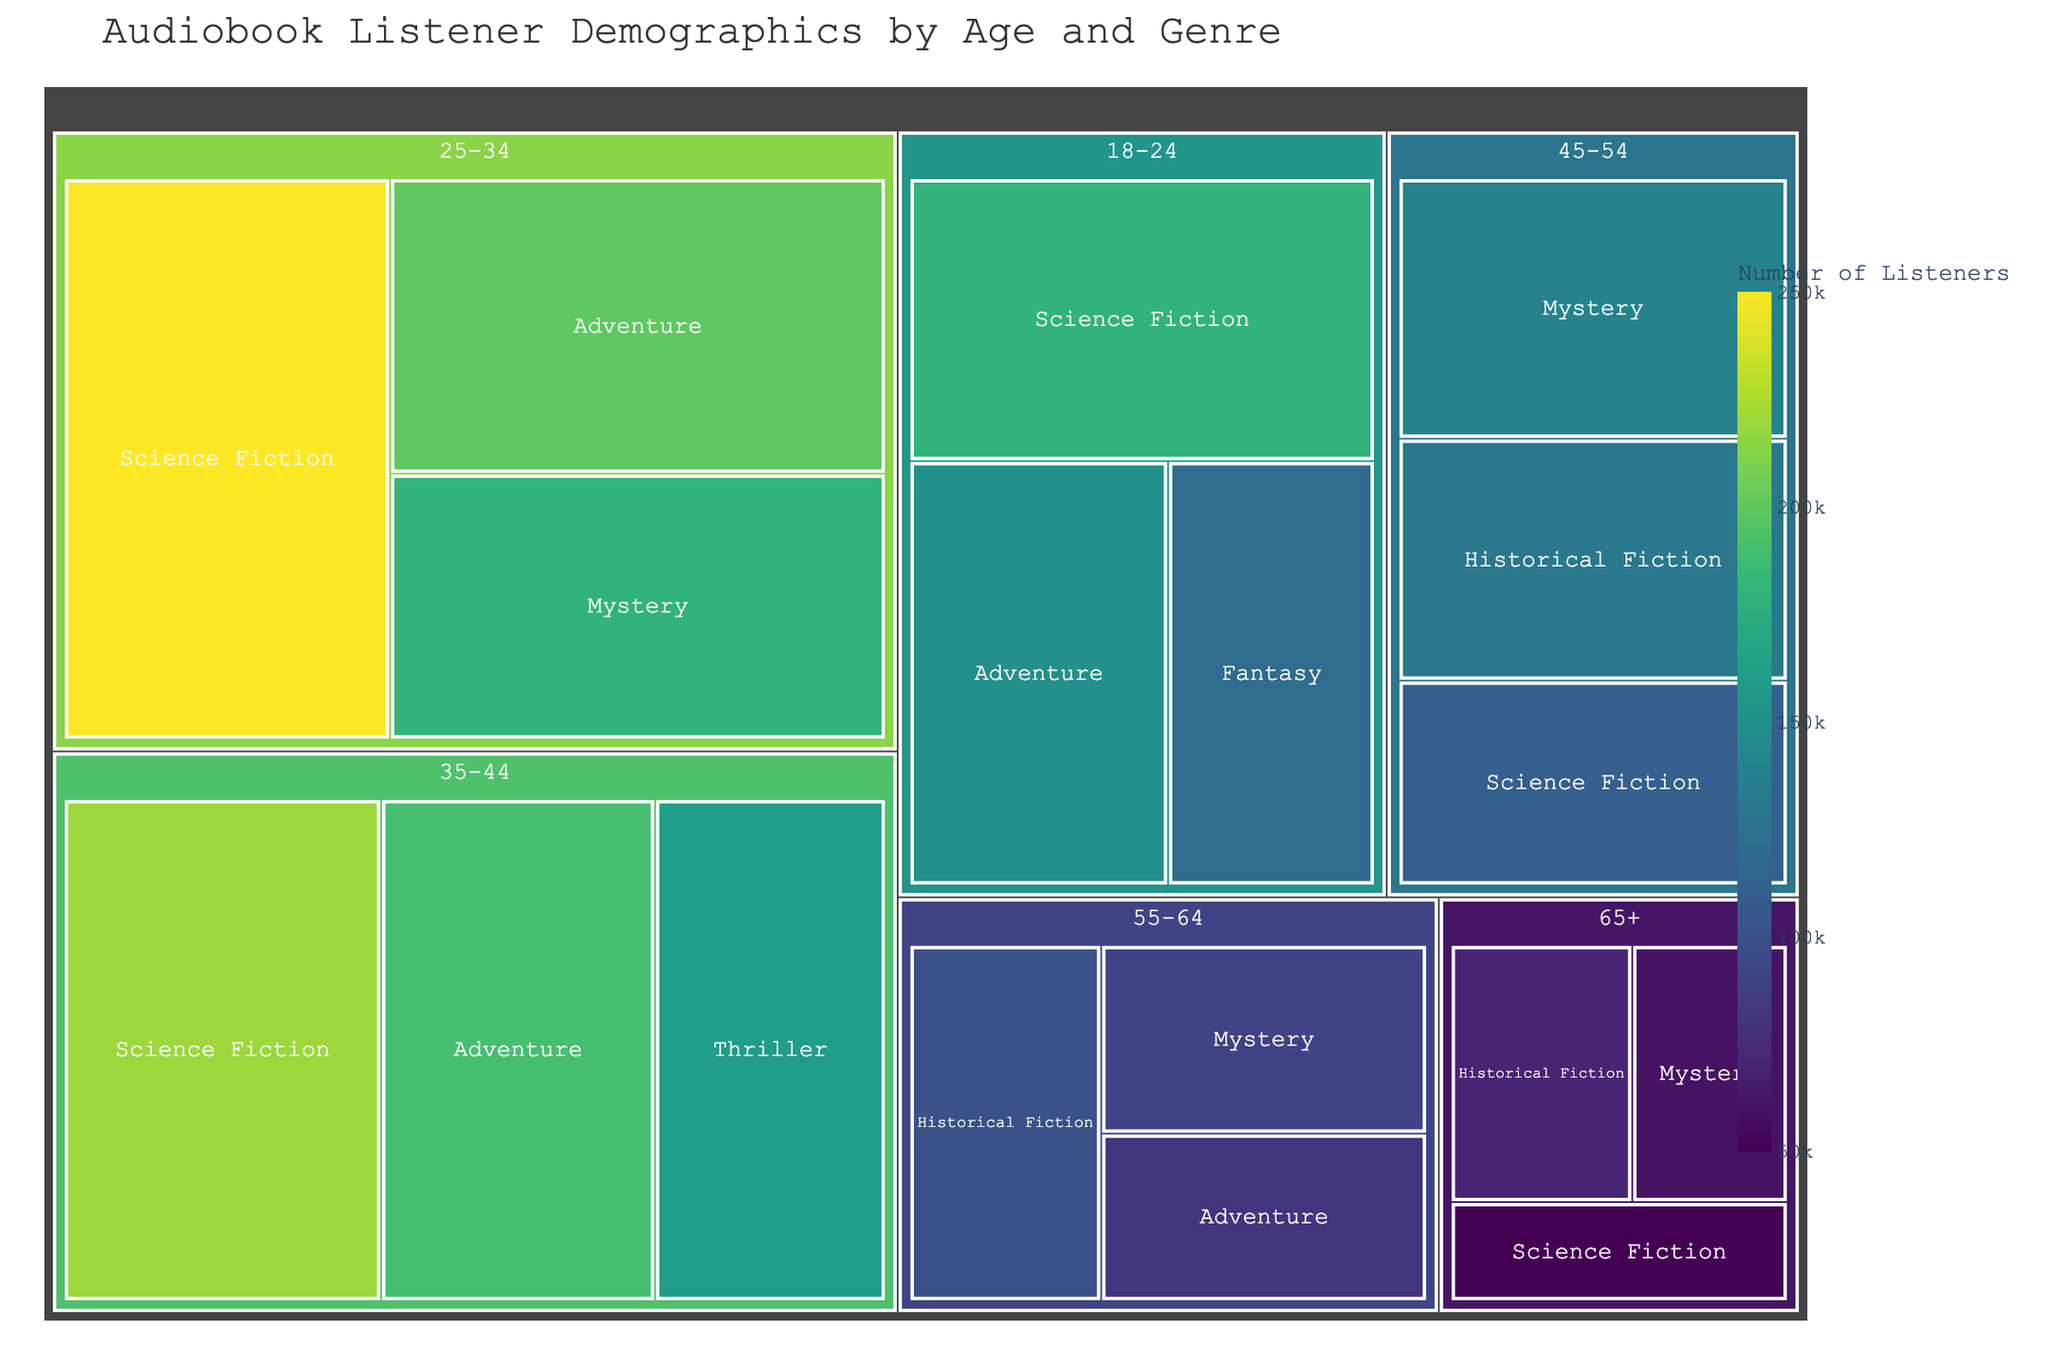What's the primary demographic for Science Fiction audiobooks? The shade of colors represents the number of listeners, increasing intensity indicates more listeners. The largest block for Science Fiction is under the 25-34 age group. By examining the sizes and colors, it's evident that this group has the most listeners.
Answer: 25-34 Which age group has the smallest number of listeners for Adventure audiobooks? Smaller size and lighter color indicate fewer listeners. Check the blocks for Adventure genre across age groups. The smallest block is under the 55-64 age group.
Answer: 55-64 How many listeners are there for Mystery audiobooks in the 25-34 age group compared to 45-54? Add the total listeners in the respective blocks. For 25-34 and 45-54, the relevant blocks under Mystery show 180,000 and 140,000 listeners, respectively. Comparing both, 25-34 has more listeners than 45-54.
Answer: 180,000 vs. 140,000 Which genre is most popular among listeners aged 35-44? By comparing the sizes and colors of blocks in 35-44 segments, the largest block corresponds to Science Fiction.
Answer: Science Fiction Is there any genre that is equally popular across two different age groups? Scan through different genres across age groups to find blocks of similar sizes and colors. Science Fiction for 35-44 and Adventure for 45-54 both share similar sizes, but close observation is necessary to ensure accuracy.
Answer: No What genre has the fewest listeners overall? The smallest, lightest block across the entire chart will identify this. Historical Fiction in the 65+ age group is the smallest.
Answer: Historical Fiction Which age group has the most diverse range of preferred genres? Evaluate age groups that show a variety of segmented blocks of different sizes and genres. The 45-54 age group has a variety of segments representing different genres like Mystery, Historical Fiction, and Science Fiction.
Answer: 45-54 What is the combined number of listeners for Science Fiction audiobooks across all age groups? Sum up all the values for the Science Fiction genre across each age group: 180,000 + 250,000 + 220,000 + 110,000 + 50,000 totals to 810,000 listeners.
Answer: 810,000 Which genre is the least popular among listeners aged 25-34? Among the segments under 25-34, the block for Mystery is the smallest in size and lightest in color, making it the least popular within the group.
Answer: Mystery How does the popularity of Adventure audiobooks in the 18-24 age group compare to Fantasy audiobooks in the same group? Compare the sizes and colors of the Adventure and Fantasy blocks in the 18-24 age group. The Adventure block is larger and darker, indicating more listeners than Fantasy.
Answer: More popular 